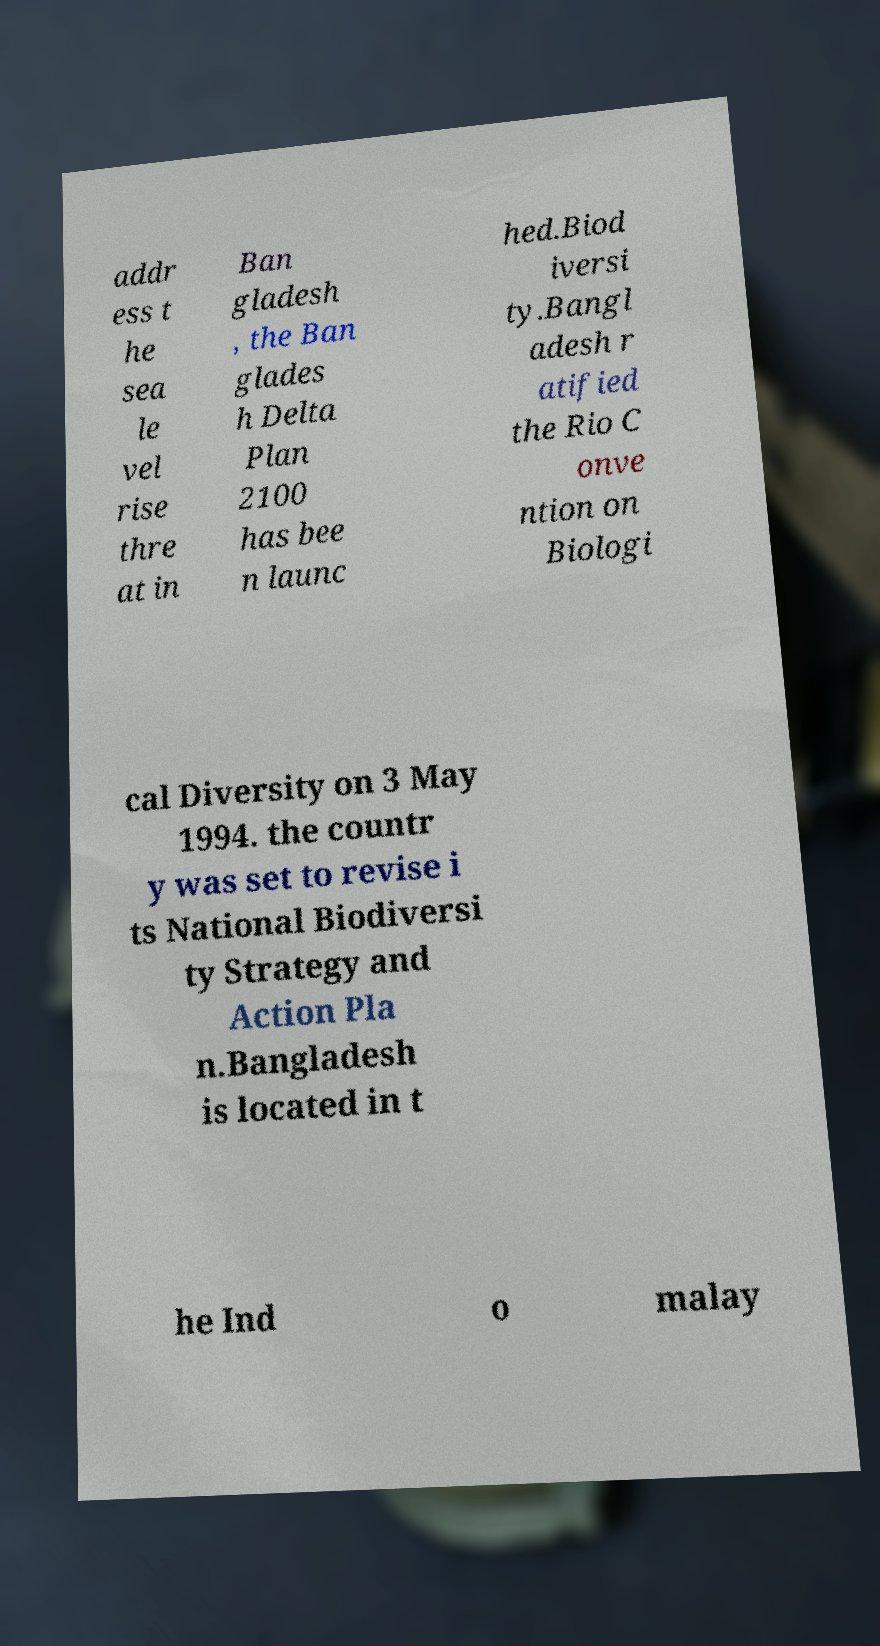Please read and relay the text visible in this image. What does it say? addr ess t he sea le vel rise thre at in Ban gladesh , the Ban glades h Delta Plan 2100 has bee n launc hed.Biod iversi ty.Bangl adesh r atified the Rio C onve ntion on Biologi cal Diversity on 3 May 1994. the countr y was set to revise i ts National Biodiversi ty Strategy and Action Pla n.Bangladesh is located in t he Ind o malay 